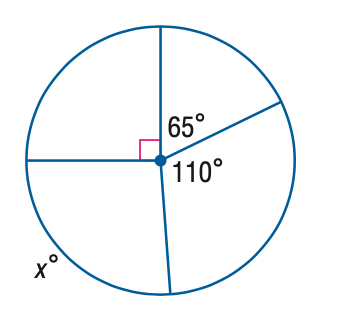Answer the mathemtical geometry problem and directly provide the correct option letter.
Question: Find the value of x.
Choices: A: 65 B: 90 C: 95 D: 110 C 